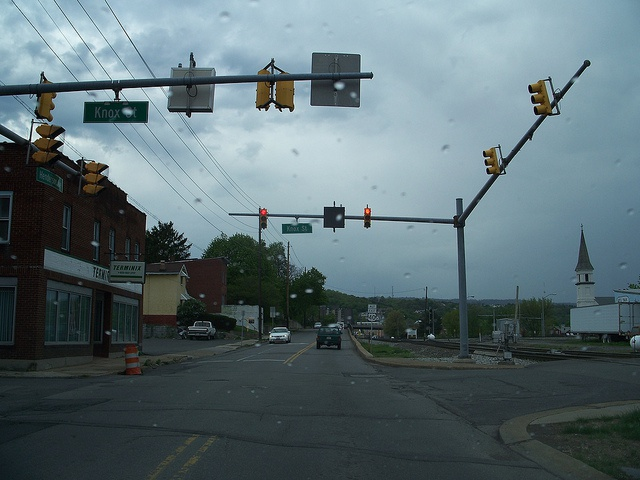Describe the objects in this image and their specific colors. I can see truck in lightblue, gray, black, purple, and darkblue tones, traffic light in lightblue, olive, black, gray, and maroon tones, traffic light in lightblue, black, maroon, and gray tones, traffic light in lightblue, black, maroon, and gray tones, and traffic light in lightblue, olive, black, and gray tones in this image. 